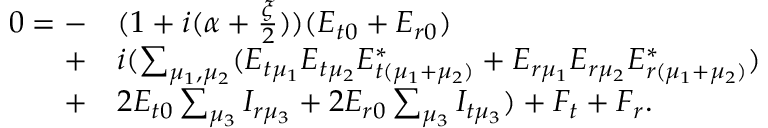<formula> <loc_0><loc_0><loc_500><loc_500>\begin{array} { r l } { 0 = - } & ( 1 + i ( \alpha + \frac { \xi } { 2 } ) ) ( E _ { t 0 } + E _ { r 0 } ) } \\ { + } & i ( \sum _ { \mu _ { 1 } , \mu _ { 2 } } ( E _ { t \mu _ { 1 } } E _ { t \mu _ { 2 } } E _ { t ( \mu _ { 1 } + \mu _ { 2 } ) } ^ { * } + E _ { r \mu _ { 1 } } E _ { r \mu _ { 2 } } E _ { r ( \mu _ { 1 } + \mu _ { 2 } ) } ^ { * } ) } \\ { + } & 2 E _ { t 0 } \sum _ { \mu _ { 3 } } I _ { r \mu _ { 3 } } + 2 E _ { r 0 } \sum _ { \mu _ { 3 } } I _ { t \mu _ { 3 } } ) + F _ { t } + F _ { r } . } \end{array}</formula> 